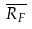<formula> <loc_0><loc_0><loc_500><loc_500>\overline { R _ { F } }</formula> 